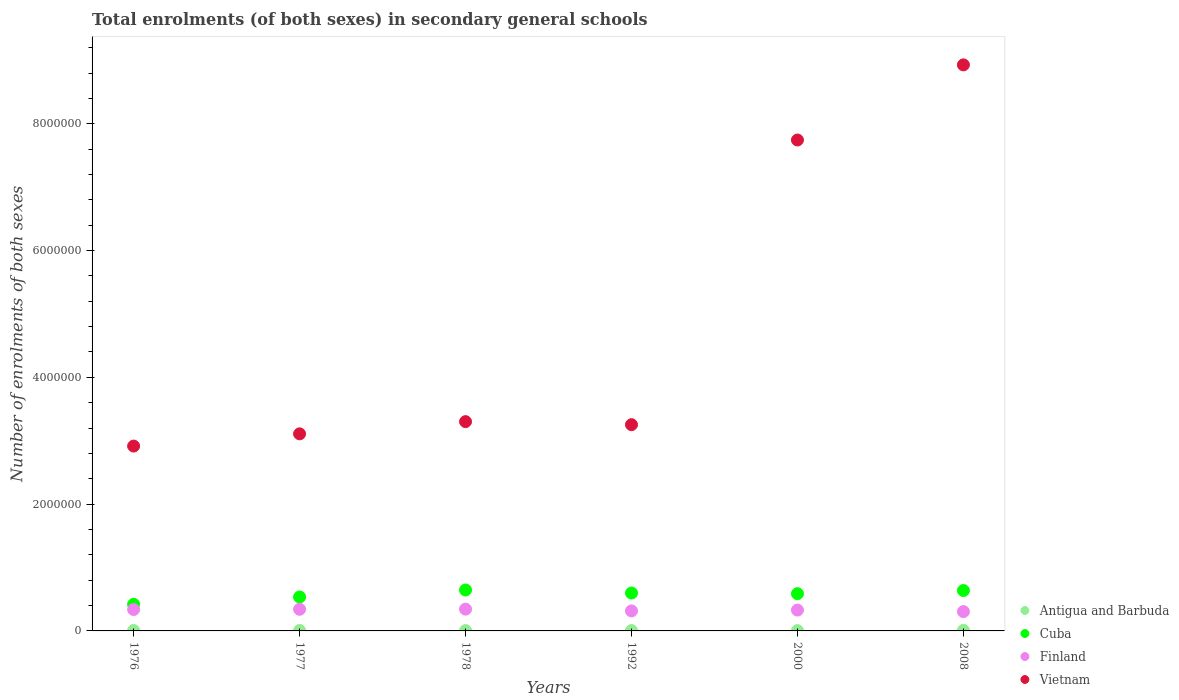Is the number of dotlines equal to the number of legend labels?
Your answer should be very brief. Yes. What is the number of enrolments in secondary schools in Cuba in 1977?
Your response must be concise. 5.35e+05. Across all years, what is the maximum number of enrolments in secondary schools in Vietnam?
Offer a very short reply. 8.93e+06. Across all years, what is the minimum number of enrolments in secondary schools in Finland?
Provide a succinct answer. 3.05e+05. In which year was the number of enrolments in secondary schools in Vietnam maximum?
Make the answer very short. 2008. In which year was the number of enrolments in secondary schools in Antigua and Barbuda minimum?
Give a very brief answer. 2000. What is the total number of enrolments in secondary schools in Cuba in the graph?
Provide a short and direct response. 3.42e+06. What is the difference between the number of enrolments in secondary schools in Finland in 1976 and that in 2008?
Make the answer very short. 3.28e+04. What is the difference between the number of enrolments in secondary schools in Antigua and Barbuda in 1992 and the number of enrolments in secondary schools in Cuba in 1977?
Offer a very short reply. -5.29e+05. What is the average number of enrolments in secondary schools in Vietnam per year?
Make the answer very short. 4.88e+06. In the year 1992, what is the difference between the number of enrolments in secondary schools in Vietnam and number of enrolments in secondary schools in Finland?
Ensure brevity in your answer.  2.94e+06. In how many years, is the number of enrolments in secondary schools in Cuba greater than 8000000?
Your answer should be very brief. 0. What is the ratio of the number of enrolments in secondary schools in Cuba in 1976 to that in 1978?
Make the answer very short. 0.65. Is the difference between the number of enrolments in secondary schools in Vietnam in 1978 and 1992 greater than the difference between the number of enrolments in secondary schools in Finland in 1978 and 1992?
Provide a short and direct response. Yes. What is the difference between the highest and the second highest number of enrolments in secondary schools in Vietnam?
Your response must be concise. 1.19e+06. What is the difference between the highest and the lowest number of enrolments in secondary schools in Antigua and Barbuda?
Offer a very short reply. 3538. In how many years, is the number of enrolments in secondary schools in Cuba greater than the average number of enrolments in secondary schools in Cuba taken over all years?
Provide a short and direct response. 4. Is the sum of the number of enrolments in secondary schools in Vietnam in 1976 and 1977 greater than the maximum number of enrolments in secondary schools in Cuba across all years?
Your answer should be very brief. Yes. Is it the case that in every year, the sum of the number of enrolments in secondary schools in Antigua and Barbuda and number of enrolments in secondary schools in Cuba  is greater than the sum of number of enrolments in secondary schools in Vietnam and number of enrolments in secondary schools in Finland?
Your answer should be compact. No. Does the number of enrolments in secondary schools in Cuba monotonically increase over the years?
Keep it short and to the point. No. Is the number of enrolments in secondary schools in Antigua and Barbuda strictly greater than the number of enrolments in secondary schools in Cuba over the years?
Offer a very short reply. No. Is the number of enrolments in secondary schools in Antigua and Barbuda strictly less than the number of enrolments in secondary schools in Cuba over the years?
Make the answer very short. Yes. What is the difference between two consecutive major ticks on the Y-axis?
Offer a terse response. 2.00e+06. Are the values on the major ticks of Y-axis written in scientific E-notation?
Your answer should be very brief. No. Does the graph contain grids?
Make the answer very short. No. Where does the legend appear in the graph?
Your response must be concise. Bottom right. How many legend labels are there?
Provide a succinct answer. 4. What is the title of the graph?
Offer a terse response. Total enrolments (of both sexes) in secondary general schools. Does "Bahrain" appear as one of the legend labels in the graph?
Provide a succinct answer. No. What is the label or title of the Y-axis?
Ensure brevity in your answer.  Number of enrolments of both sexes. What is the Number of enrolments of both sexes of Antigua and Barbuda in 1976?
Your answer should be compact. 6629. What is the Number of enrolments of both sexes in Cuba in 1976?
Provide a short and direct response. 4.20e+05. What is the Number of enrolments of both sexes in Finland in 1976?
Your response must be concise. 3.38e+05. What is the Number of enrolments of both sexes of Vietnam in 1976?
Ensure brevity in your answer.  2.92e+06. What is the Number of enrolments of both sexes of Antigua and Barbuda in 1977?
Offer a very short reply. 6685. What is the Number of enrolments of both sexes of Cuba in 1977?
Provide a short and direct response. 5.35e+05. What is the Number of enrolments of both sexes in Finland in 1977?
Keep it short and to the point. 3.41e+05. What is the Number of enrolments of both sexes in Vietnam in 1977?
Make the answer very short. 3.11e+06. What is the Number of enrolments of both sexes in Antigua and Barbuda in 1978?
Provide a succinct answer. 5458. What is the Number of enrolments of both sexes of Cuba in 1978?
Your answer should be compact. 6.46e+05. What is the Number of enrolments of both sexes in Finland in 1978?
Offer a terse response. 3.44e+05. What is the Number of enrolments of both sexes of Vietnam in 1978?
Your answer should be very brief. 3.30e+06. What is the Number of enrolments of both sexes in Antigua and Barbuda in 1992?
Give a very brief answer. 5845. What is the Number of enrolments of both sexes in Cuba in 1992?
Your answer should be very brief. 5.98e+05. What is the Number of enrolments of both sexes of Finland in 1992?
Your response must be concise. 3.16e+05. What is the Number of enrolments of both sexes of Vietnam in 1992?
Your answer should be very brief. 3.25e+06. What is the Number of enrolments of both sexes in Antigua and Barbuda in 2000?
Your response must be concise. 4576. What is the Number of enrolments of both sexes of Cuba in 2000?
Ensure brevity in your answer.  5.88e+05. What is the Number of enrolments of both sexes in Finland in 2000?
Give a very brief answer. 3.29e+05. What is the Number of enrolments of both sexes in Vietnam in 2000?
Offer a terse response. 7.74e+06. What is the Number of enrolments of both sexes in Antigua and Barbuda in 2008?
Keep it short and to the point. 8114. What is the Number of enrolments of both sexes of Cuba in 2008?
Your answer should be very brief. 6.37e+05. What is the Number of enrolments of both sexes of Finland in 2008?
Offer a very short reply. 3.05e+05. What is the Number of enrolments of both sexes in Vietnam in 2008?
Keep it short and to the point. 8.93e+06. Across all years, what is the maximum Number of enrolments of both sexes in Antigua and Barbuda?
Your answer should be very brief. 8114. Across all years, what is the maximum Number of enrolments of both sexes in Cuba?
Make the answer very short. 6.46e+05. Across all years, what is the maximum Number of enrolments of both sexes of Finland?
Offer a very short reply. 3.44e+05. Across all years, what is the maximum Number of enrolments of both sexes of Vietnam?
Your answer should be compact. 8.93e+06. Across all years, what is the minimum Number of enrolments of both sexes of Antigua and Barbuda?
Offer a terse response. 4576. Across all years, what is the minimum Number of enrolments of both sexes of Cuba?
Your response must be concise. 4.20e+05. Across all years, what is the minimum Number of enrolments of both sexes in Finland?
Give a very brief answer. 3.05e+05. Across all years, what is the minimum Number of enrolments of both sexes in Vietnam?
Offer a terse response. 2.92e+06. What is the total Number of enrolments of both sexes of Antigua and Barbuda in the graph?
Your answer should be very brief. 3.73e+04. What is the total Number of enrolments of both sexes in Cuba in the graph?
Keep it short and to the point. 3.42e+06. What is the total Number of enrolments of both sexes in Finland in the graph?
Provide a short and direct response. 1.97e+06. What is the total Number of enrolments of both sexes of Vietnam in the graph?
Your answer should be compact. 2.93e+07. What is the difference between the Number of enrolments of both sexes in Antigua and Barbuda in 1976 and that in 1977?
Your answer should be very brief. -56. What is the difference between the Number of enrolments of both sexes in Cuba in 1976 and that in 1977?
Keep it short and to the point. -1.15e+05. What is the difference between the Number of enrolments of both sexes in Finland in 1976 and that in 1977?
Your response must be concise. -3846. What is the difference between the Number of enrolments of both sexes in Vietnam in 1976 and that in 1977?
Offer a very short reply. -1.93e+05. What is the difference between the Number of enrolments of both sexes in Antigua and Barbuda in 1976 and that in 1978?
Provide a short and direct response. 1171. What is the difference between the Number of enrolments of both sexes in Cuba in 1976 and that in 1978?
Keep it short and to the point. -2.25e+05. What is the difference between the Number of enrolments of both sexes of Finland in 1976 and that in 1978?
Offer a terse response. -6184. What is the difference between the Number of enrolments of both sexes in Vietnam in 1976 and that in 1978?
Provide a succinct answer. -3.85e+05. What is the difference between the Number of enrolments of both sexes of Antigua and Barbuda in 1976 and that in 1992?
Keep it short and to the point. 784. What is the difference between the Number of enrolments of both sexes in Cuba in 1976 and that in 1992?
Your answer should be very brief. -1.78e+05. What is the difference between the Number of enrolments of both sexes of Finland in 1976 and that in 1992?
Your response must be concise. 2.17e+04. What is the difference between the Number of enrolments of both sexes in Vietnam in 1976 and that in 1992?
Your response must be concise. -3.37e+05. What is the difference between the Number of enrolments of both sexes in Antigua and Barbuda in 1976 and that in 2000?
Keep it short and to the point. 2053. What is the difference between the Number of enrolments of both sexes in Cuba in 1976 and that in 2000?
Provide a short and direct response. -1.67e+05. What is the difference between the Number of enrolments of both sexes of Finland in 1976 and that in 2000?
Make the answer very short. 8926. What is the difference between the Number of enrolments of both sexes in Vietnam in 1976 and that in 2000?
Make the answer very short. -4.83e+06. What is the difference between the Number of enrolments of both sexes of Antigua and Barbuda in 1976 and that in 2008?
Provide a short and direct response. -1485. What is the difference between the Number of enrolments of both sexes of Cuba in 1976 and that in 2008?
Keep it short and to the point. -2.17e+05. What is the difference between the Number of enrolments of both sexes in Finland in 1976 and that in 2008?
Your response must be concise. 3.28e+04. What is the difference between the Number of enrolments of both sexes of Vietnam in 1976 and that in 2008?
Your response must be concise. -6.01e+06. What is the difference between the Number of enrolments of both sexes in Antigua and Barbuda in 1977 and that in 1978?
Provide a short and direct response. 1227. What is the difference between the Number of enrolments of both sexes of Cuba in 1977 and that in 1978?
Your answer should be very brief. -1.10e+05. What is the difference between the Number of enrolments of both sexes of Finland in 1977 and that in 1978?
Your answer should be compact. -2338. What is the difference between the Number of enrolments of both sexes in Vietnam in 1977 and that in 1978?
Your response must be concise. -1.93e+05. What is the difference between the Number of enrolments of both sexes of Antigua and Barbuda in 1977 and that in 1992?
Offer a very short reply. 840. What is the difference between the Number of enrolments of both sexes in Cuba in 1977 and that in 1992?
Keep it short and to the point. -6.29e+04. What is the difference between the Number of enrolments of both sexes of Finland in 1977 and that in 1992?
Your answer should be very brief. 2.56e+04. What is the difference between the Number of enrolments of both sexes in Vietnam in 1977 and that in 1992?
Your answer should be very brief. -1.44e+05. What is the difference between the Number of enrolments of both sexes in Antigua and Barbuda in 1977 and that in 2000?
Your response must be concise. 2109. What is the difference between the Number of enrolments of both sexes in Cuba in 1977 and that in 2000?
Make the answer very short. -5.25e+04. What is the difference between the Number of enrolments of both sexes of Finland in 1977 and that in 2000?
Make the answer very short. 1.28e+04. What is the difference between the Number of enrolments of both sexes in Vietnam in 1977 and that in 2000?
Provide a short and direct response. -4.63e+06. What is the difference between the Number of enrolments of both sexes in Antigua and Barbuda in 1977 and that in 2008?
Provide a short and direct response. -1429. What is the difference between the Number of enrolments of both sexes of Cuba in 1977 and that in 2008?
Offer a very short reply. -1.02e+05. What is the difference between the Number of enrolments of both sexes in Finland in 1977 and that in 2008?
Your answer should be very brief. 3.67e+04. What is the difference between the Number of enrolments of both sexes in Vietnam in 1977 and that in 2008?
Give a very brief answer. -5.82e+06. What is the difference between the Number of enrolments of both sexes in Antigua and Barbuda in 1978 and that in 1992?
Your answer should be very brief. -387. What is the difference between the Number of enrolments of both sexes in Cuba in 1978 and that in 1992?
Provide a short and direct response. 4.76e+04. What is the difference between the Number of enrolments of both sexes in Finland in 1978 and that in 1992?
Your response must be concise. 2.79e+04. What is the difference between the Number of enrolments of both sexes in Vietnam in 1978 and that in 1992?
Offer a terse response. 4.80e+04. What is the difference between the Number of enrolments of both sexes of Antigua and Barbuda in 1978 and that in 2000?
Provide a succinct answer. 882. What is the difference between the Number of enrolments of both sexes in Cuba in 1978 and that in 2000?
Make the answer very short. 5.79e+04. What is the difference between the Number of enrolments of both sexes of Finland in 1978 and that in 2000?
Offer a very short reply. 1.51e+04. What is the difference between the Number of enrolments of both sexes of Vietnam in 1978 and that in 2000?
Your answer should be compact. -4.44e+06. What is the difference between the Number of enrolments of both sexes of Antigua and Barbuda in 1978 and that in 2008?
Offer a very short reply. -2656. What is the difference between the Number of enrolments of both sexes in Cuba in 1978 and that in 2008?
Ensure brevity in your answer.  8411. What is the difference between the Number of enrolments of both sexes of Finland in 1978 and that in 2008?
Your response must be concise. 3.90e+04. What is the difference between the Number of enrolments of both sexes of Vietnam in 1978 and that in 2008?
Your answer should be compact. -5.63e+06. What is the difference between the Number of enrolments of both sexes in Antigua and Barbuda in 1992 and that in 2000?
Keep it short and to the point. 1269. What is the difference between the Number of enrolments of both sexes of Cuba in 1992 and that in 2000?
Provide a succinct answer. 1.04e+04. What is the difference between the Number of enrolments of both sexes of Finland in 1992 and that in 2000?
Your answer should be very brief. -1.28e+04. What is the difference between the Number of enrolments of both sexes in Vietnam in 1992 and that in 2000?
Provide a short and direct response. -4.49e+06. What is the difference between the Number of enrolments of both sexes in Antigua and Barbuda in 1992 and that in 2008?
Offer a very short reply. -2269. What is the difference between the Number of enrolments of both sexes in Cuba in 1992 and that in 2008?
Ensure brevity in your answer.  -3.92e+04. What is the difference between the Number of enrolments of both sexes of Finland in 1992 and that in 2008?
Provide a short and direct response. 1.11e+04. What is the difference between the Number of enrolments of both sexes in Vietnam in 1992 and that in 2008?
Offer a terse response. -5.68e+06. What is the difference between the Number of enrolments of both sexes of Antigua and Barbuda in 2000 and that in 2008?
Provide a short and direct response. -3538. What is the difference between the Number of enrolments of both sexes in Cuba in 2000 and that in 2008?
Your answer should be compact. -4.95e+04. What is the difference between the Number of enrolments of both sexes in Finland in 2000 and that in 2008?
Offer a very short reply. 2.39e+04. What is the difference between the Number of enrolments of both sexes in Vietnam in 2000 and that in 2008?
Keep it short and to the point. -1.19e+06. What is the difference between the Number of enrolments of both sexes of Antigua and Barbuda in 1976 and the Number of enrolments of both sexes of Cuba in 1977?
Your answer should be compact. -5.28e+05. What is the difference between the Number of enrolments of both sexes of Antigua and Barbuda in 1976 and the Number of enrolments of both sexes of Finland in 1977?
Give a very brief answer. -3.35e+05. What is the difference between the Number of enrolments of both sexes of Antigua and Barbuda in 1976 and the Number of enrolments of both sexes of Vietnam in 1977?
Your response must be concise. -3.10e+06. What is the difference between the Number of enrolments of both sexes in Cuba in 1976 and the Number of enrolments of both sexes in Finland in 1977?
Ensure brevity in your answer.  7.89e+04. What is the difference between the Number of enrolments of both sexes in Cuba in 1976 and the Number of enrolments of both sexes in Vietnam in 1977?
Offer a terse response. -2.69e+06. What is the difference between the Number of enrolments of both sexes in Finland in 1976 and the Number of enrolments of both sexes in Vietnam in 1977?
Keep it short and to the point. -2.77e+06. What is the difference between the Number of enrolments of both sexes in Antigua and Barbuda in 1976 and the Number of enrolments of both sexes in Cuba in 1978?
Give a very brief answer. -6.39e+05. What is the difference between the Number of enrolments of both sexes of Antigua and Barbuda in 1976 and the Number of enrolments of both sexes of Finland in 1978?
Ensure brevity in your answer.  -3.37e+05. What is the difference between the Number of enrolments of both sexes of Antigua and Barbuda in 1976 and the Number of enrolments of both sexes of Vietnam in 1978?
Offer a terse response. -3.29e+06. What is the difference between the Number of enrolments of both sexes in Cuba in 1976 and the Number of enrolments of both sexes in Finland in 1978?
Ensure brevity in your answer.  7.66e+04. What is the difference between the Number of enrolments of both sexes of Cuba in 1976 and the Number of enrolments of both sexes of Vietnam in 1978?
Your response must be concise. -2.88e+06. What is the difference between the Number of enrolments of both sexes in Finland in 1976 and the Number of enrolments of both sexes in Vietnam in 1978?
Offer a very short reply. -2.96e+06. What is the difference between the Number of enrolments of both sexes in Antigua and Barbuda in 1976 and the Number of enrolments of both sexes in Cuba in 1992?
Make the answer very short. -5.91e+05. What is the difference between the Number of enrolments of both sexes in Antigua and Barbuda in 1976 and the Number of enrolments of both sexes in Finland in 1992?
Your answer should be very brief. -3.09e+05. What is the difference between the Number of enrolments of both sexes in Antigua and Barbuda in 1976 and the Number of enrolments of both sexes in Vietnam in 1992?
Offer a very short reply. -3.25e+06. What is the difference between the Number of enrolments of both sexes of Cuba in 1976 and the Number of enrolments of both sexes of Finland in 1992?
Your answer should be compact. 1.04e+05. What is the difference between the Number of enrolments of both sexes of Cuba in 1976 and the Number of enrolments of both sexes of Vietnam in 1992?
Provide a short and direct response. -2.83e+06. What is the difference between the Number of enrolments of both sexes of Finland in 1976 and the Number of enrolments of both sexes of Vietnam in 1992?
Your response must be concise. -2.92e+06. What is the difference between the Number of enrolments of both sexes in Antigua and Barbuda in 1976 and the Number of enrolments of both sexes in Cuba in 2000?
Provide a short and direct response. -5.81e+05. What is the difference between the Number of enrolments of both sexes in Antigua and Barbuda in 1976 and the Number of enrolments of both sexes in Finland in 2000?
Make the answer very short. -3.22e+05. What is the difference between the Number of enrolments of both sexes of Antigua and Barbuda in 1976 and the Number of enrolments of both sexes of Vietnam in 2000?
Your response must be concise. -7.74e+06. What is the difference between the Number of enrolments of both sexes in Cuba in 1976 and the Number of enrolments of both sexes in Finland in 2000?
Your answer should be very brief. 9.17e+04. What is the difference between the Number of enrolments of both sexes in Cuba in 1976 and the Number of enrolments of both sexes in Vietnam in 2000?
Provide a succinct answer. -7.32e+06. What is the difference between the Number of enrolments of both sexes in Finland in 1976 and the Number of enrolments of both sexes in Vietnam in 2000?
Provide a succinct answer. -7.41e+06. What is the difference between the Number of enrolments of both sexes in Antigua and Barbuda in 1976 and the Number of enrolments of both sexes in Cuba in 2008?
Give a very brief answer. -6.31e+05. What is the difference between the Number of enrolments of both sexes of Antigua and Barbuda in 1976 and the Number of enrolments of both sexes of Finland in 2008?
Ensure brevity in your answer.  -2.98e+05. What is the difference between the Number of enrolments of both sexes of Antigua and Barbuda in 1976 and the Number of enrolments of both sexes of Vietnam in 2008?
Your answer should be very brief. -8.92e+06. What is the difference between the Number of enrolments of both sexes in Cuba in 1976 and the Number of enrolments of both sexes in Finland in 2008?
Your answer should be very brief. 1.16e+05. What is the difference between the Number of enrolments of both sexes of Cuba in 1976 and the Number of enrolments of both sexes of Vietnam in 2008?
Make the answer very short. -8.51e+06. What is the difference between the Number of enrolments of both sexes of Finland in 1976 and the Number of enrolments of both sexes of Vietnam in 2008?
Ensure brevity in your answer.  -8.59e+06. What is the difference between the Number of enrolments of both sexes of Antigua and Barbuda in 1977 and the Number of enrolments of both sexes of Cuba in 1978?
Provide a succinct answer. -6.39e+05. What is the difference between the Number of enrolments of both sexes of Antigua and Barbuda in 1977 and the Number of enrolments of both sexes of Finland in 1978?
Make the answer very short. -3.37e+05. What is the difference between the Number of enrolments of both sexes of Antigua and Barbuda in 1977 and the Number of enrolments of both sexes of Vietnam in 1978?
Your answer should be very brief. -3.29e+06. What is the difference between the Number of enrolments of both sexes of Cuba in 1977 and the Number of enrolments of both sexes of Finland in 1978?
Keep it short and to the point. 1.91e+05. What is the difference between the Number of enrolments of both sexes in Cuba in 1977 and the Number of enrolments of both sexes in Vietnam in 1978?
Provide a succinct answer. -2.77e+06. What is the difference between the Number of enrolments of both sexes of Finland in 1977 and the Number of enrolments of both sexes of Vietnam in 1978?
Ensure brevity in your answer.  -2.96e+06. What is the difference between the Number of enrolments of both sexes in Antigua and Barbuda in 1977 and the Number of enrolments of both sexes in Cuba in 1992?
Offer a very short reply. -5.91e+05. What is the difference between the Number of enrolments of both sexes in Antigua and Barbuda in 1977 and the Number of enrolments of both sexes in Finland in 1992?
Ensure brevity in your answer.  -3.09e+05. What is the difference between the Number of enrolments of both sexes of Antigua and Barbuda in 1977 and the Number of enrolments of both sexes of Vietnam in 1992?
Provide a succinct answer. -3.25e+06. What is the difference between the Number of enrolments of both sexes of Cuba in 1977 and the Number of enrolments of both sexes of Finland in 1992?
Give a very brief answer. 2.19e+05. What is the difference between the Number of enrolments of both sexes of Cuba in 1977 and the Number of enrolments of both sexes of Vietnam in 1992?
Give a very brief answer. -2.72e+06. What is the difference between the Number of enrolments of both sexes of Finland in 1977 and the Number of enrolments of both sexes of Vietnam in 1992?
Keep it short and to the point. -2.91e+06. What is the difference between the Number of enrolments of both sexes of Antigua and Barbuda in 1977 and the Number of enrolments of both sexes of Cuba in 2000?
Your answer should be very brief. -5.81e+05. What is the difference between the Number of enrolments of both sexes in Antigua and Barbuda in 1977 and the Number of enrolments of both sexes in Finland in 2000?
Provide a short and direct response. -3.22e+05. What is the difference between the Number of enrolments of both sexes of Antigua and Barbuda in 1977 and the Number of enrolments of both sexes of Vietnam in 2000?
Offer a terse response. -7.74e+06. What is the difference between the Number of enrolments of both sexes of Cuba in 1977 and the Number of enrolments of both sexes of Finland in 2000?
Offer a very short reply. 2.06e+05. What is the difference between the Number of enrolments of both sexes in Cuba in 1977 and the Number of enrolments of both sexes in Vietnam in 2000?
Provide a succinct answer. -7.21e+06. What is the difference between the Number of enrolments of both sexes in Finland in 1977 and the Number of enrolments of both sexes in Vietnam in 2000?
Give a very brief answer. -7.40e+06. What is the difference between the Number of enrolments of both sexes in Antigua and Barbuda in 1977 and the Number of enrolments of both sexes in Cuba in 2008?
Ensure brevity in your answer.  -6.30e+05. What is the difference between the Number of enrolments of both sexes in Antigua and Barbuda in 1977 and the Number of enrolments of both sexes in Finland in 2008?
Provide a short and direct response. -2.98e+05. What is the difference between the Number of enrolments of both sexes of Antigua and Barbuda in 1977 and the Number of enrolments of both sexes of Vietnam in 2008?
Give a very brief answer. -8.92e+06. What is the difference between the Number of enrolments of both sexes of Cuba in 1977 and the Number of enrolments of both sexes of Finland in 2008?
Keep it short and to the point. 2.30e+05. What is the difference between the Number of enrolments of both sexes of Cuba in 1977 and the Number of enrolments of both sexes of Vietnam in 2008?
Provide a succinct answer. -8.39e+06. What is the difference between the Number of enrolments of both sexes in Finland in 1977 and the Number of enrolments of both sexes in Vietnam in 2008?
Give a very brief answer. -8.59e+06. What is the difference between the Number of enrolments of both sexes in Antigua and Barbuda in 1978 and the Number of enrolments of both sexes in Cuba in 1992?
Your response must be concise. -5.93e+05. What is the difference between the Number of enrolments of both sexes in Antigua and Barbuda in 1978 and the Number of enrolments of both sexes in Finland in 1992?
Your response must be concise. -3.10e+05. What is the difference between the Number of enrolments of both sexes of Antigua and Barbuda in 1978 and the Number of enrolments of both sexes of Vietnam in 1992?
Ensure brevity in your answer.  -3.25e+06. What is the difference between the Number of enrolments of both sexes in Cuba in 1978 and the Number of enrolments of both sexes in Finland in 1992?
Your response must be concise. 3.30e+05. What is the difference between the Number of enrolments of both sexes of Cuba in 1978 and the Number of enrolments of both sexes of Vietnam in 1992?
Provide a short and direct response. -2.61e+06. What is the difference between the Number of enrolments of both sexes in Finland in 1978 and the Number of enrolments of both sexes in Vietnam in 1992?
Ensure brevity in your answer.  -2.91e+06. What is the difference between the Number of enrolments of both sexes of Antigua and Barbuda in 1978 and the Number of enrolments of both sexes of Cuba in 2000?
Make the answer very short. -5.82e+05. What is the difference between the Number of enrolments of both sexes of Antigua and Barbuda in 1978 and the Number of enrolments of both sexes of Finland in 2000?
Offer a terse response. -3.23e+05. What is the difference between the Number of enrolments of both sexes of Antigua and Barbuda in 1978 and the Number of enrolments of both sexes of Vietnam in 2000?
Provide a succinct answer. -7.74e+06. What is the difference between the Number of enrolments of both sexes in Cuba in 1978 and the Number of enrolments of both sexes in Finland in 2000?
Offer a terse response. 3.17e+05. What is the difference between the Number of enrolments of both sexes of Cuba in 1978 and the Number of enrolments of both sexes of Vietnam in 2000?
Provide a succinct answer. -7.10e+06. What is the difference between the Number of enrolments of both sexes of Finland in 1978 and the Number of enrolments of both sexes of Vietnam in 2000?
Offer a very short reply. -7.40e+06. What is the difference between the Number of enrolments of both sexes of Antigua and Barbuda in 1978 and the Number of enrolments of both sexes of Cuba in 2008?
Offer a very short reply. -6.32e+05. What is the difference between the Number of enrolments of both sexes of Antigua and Barbuda in 1978 and the Number of enrolments of both sexes of Finland in 2008?
Provide a short and direct response. -2.99e+05. What is the difference between the Number of enrolments of both sexes of Antigua and Barbuda in 1978 and the Number of enrolments of both sexes of Vietnam in 2008?
Give a very brief answer. -8.92e+06. What is the difference between the Number of enrolments of both sexes in Cuba in 1978 and the Number of enrolments of both sexes in Finland in 2008?
Keep it short and to the point. 3.41e+05. What is the difference between the Number of enrolments of both sexes in Cuba in 1978 and the Number of enrolments of both sexes in Vietnam in 2008?
Offer a very short reply. -8.28e+06. What is the difference between the Number of enrolments of both sexes of Finland in 1978 and the Number of enrolments of both sexes of Vietnam in 2008?
Keep it short and to the point. -8.58e+06. What is the difference between the Number of enrolments of both sexes in Antigua and Barbuda in 1992 and the Number of enrolments of both sexes in Cuba in 2000?
Your answer should be compact. -5.82e+05. What is the difference between the Number of enrolments of both sexes of Antigua and Barbuda in 1992 and the Number of enrolments of both sexes of Finland in 2000?
Ensure brevity in your answer.  -3.23e+05. What is the difference between the Number of enrolments of both sexes of Antigua and Barbuda in 1992 and the Number of enrolments of both sexes of Vietnam in 2000?
Your answer should be compact. -7.74e+06. What is the difference between the Number of enrolments of both sexes in Cuba in 1992 and the Number of enrolments of both sexes in Finland in 2000?
Keep it short and to the point. 2.69e+05. What is the difference between the Number of enrolments of both sexes of Cuba in 1992 and the Number of enrolments of both sexes of Vietnam in 2000?
Provide a short and direct response. -7.15e+06. What is the difference between the Number of enrolments of both sexes of Finland in 1992 and the Number of enrolments of both sexes of Vietnam in 2000?
Your response must be concise. -7.43e+06. What is the difference between the Number of enrolments of both sexes of Antigua and Barbuda in 1992 and the Number of enrolments of both sexes of Cuba in 2008?
Give a very brief answer. -6.31e+05. What is the difference between the Number of enrolments of both sexes of Antigua and Barbuda in 1992 and the Number of enrolments of both sexes of Finland in 2008?
Ensure brevity in your answer.  -2.99e+05. What is the difference between the Number of enrolments of both sexes of Antigua and Barbuda in 1992 and the Number of enrolments of both sexes of Vietnam in 2008?
Make the answer very short. -8.92e+06. What is the difference between the Number of enrolments of both sexes of Cuba in 1992 and the Number of enrolments of both sexes of Finland in 2008?
Provide a short and direct response. 2.93e+05. What is the difference between the Number of enrolments of both sexes in Cuba in 1992 and the Number of enrolments of both sexes in Vietnam in 2008?
Offer a terse response. -8.33e+06. What is the difference between the Number of enrolments of both sexes of Finland in 1992 and the Number of enrolments of both sexes of Vietnam in 2008?
Make the answer very short. -8.61e+06. What is the difference between the Number of enrolments of both sexes in Antigua and Barbuda in 2000 and the Number of enrolments of both sexes in Cuba in 2008?
Ensure brevity in your answer.  -6.33e+05. What is the difference between the Number of enrolments of both sexes in Antigua and Barbuda in 2000 and the Number of enrolments of both sexes in Finland in 2008?
Keep it short and to the point. -3.00e+05. What is the difference between the Number of enrolments of both sexes in Antigua and Barbuda in 2000 and the Number of enrolments of both sexes in Vietnam in 2008?
Offer a terse response. -8.92e+06. What is the difference between the Number of enrolments of both sexes in Cuba in 2000 and the Number of enrolments of both sexes in Finland in 2008?
Keep it short and to the point. 2.83e+05. What is the difference between the Number of enrolments of both sexes of Cuba in 2000 and the Number of enrolments of both sexes of Vietnam in 2008?
Your answer should be very brief. -8.34e+06. What is the difference between the Number of enrolments of both sexes of Finland in 2000 and the Number of enrolments of both sexes of Vietnam in 2008?
Provide a succinct answer. -8.60e+06. What is the average Number of enrolments of both sexes of Antigua and Barbuda per year?
Provide a succinct answer. 6217.83. What is the average Number of enrolments of both sexes of Cuba per year?
Ensure brevity in your answer.  5.71e+05. What is the average Number of enrolments of both sexes in Finland per year?
Offer a very short reply. 3.29e+05. What is the average Number of enrolments of both sexes in Vietnam per year?
Keep it short and to the point. 4.88e+06. In the year 1976, what is the difference between the Number of enrolments of both sexes in Antigua and Barbuda and Number of enrolments of both sexes in Cuba?
Your answer should be very brief. -4.14e+05. In the year 1976, what is the difference between the Number of enrolments of both sexes in Antigua and Barbuda and Number of enrolments of both sexes in Finland?
Ensure brevity in your answer.  -3.31e+05. In the year 1976, what is the difference between the Number of enrolments of both sexes in Antigua and Barbuda and Number of enrolments of both sexes in Vietnam?
Your response must be concise. -2.91e+06. In the year 1976, what is the difference between the Number of enrolments of both sexes of Cuba and Number of enrolments of both sexes of Finland?
Provide a short and direct response. 8.27e+04. In the year 1976, what is the difference between the Number of enrolments of both sexes of Cuba and Number of enrolments of both sexes of Vietnam?
Keep it short and to the point. -2.50e+06. In the year 1976, what is the difference between the Number of enrolments of both sexes of Finland and Number of enrolments of both sexes of Vietnam?
Provide a succinct answer. -2.58e+06. In the year 1977, what is the difference between the Number of enrolments of both sexes of Antigua and Barbuda and Number of enrolments of both sexes of Cuba?
Ensure brevity in your answer.  -5.28e+05. In the year 1977, what is the difference between the Number of enrolments of both sexes in Antigua and Barbuda and Number of enrolments of both sexes in Finland?
Provide a short and direct response. -3.35e+05. In the year 1977, what is the difference between the Number of enrolments of both sexes of Antigua and Barbuda and Number of enrolments of both sexes of Vietnam?
Provide a short and direct response. -3.10e+06. In the year 1977, what is the difference between the Number of enrolments of both sexes of Cuba and Number of enrolments of both sexes of Finland?
Ensure brevity in your answer.  1.94e+05. In the year 1977, what is the difference between the Number of enrolments of both sexes in Cuba and Number of enrolments of both sexes in Vietnam?
Your response must be concise. -2.57e+06. In the year 1977, what is the difference between the Number of enrolments of both sexes of Finland and Number of enrolments of both sexes of Vietnam?
Your answer should be very brief. -2.77e+06. In the year 1978, what is the difference between the Number of enrolments of both sexes in Antigua and Barbuda and Number of enrolments of both sexes in Cuba?
Your answer should be very brief. -6.40e+05. In the year 1978, what is the difference between the Number of enrolments of both sexes of Antigua and Barbuda and Number of enrolments of both sexes of Finland?
Give a very brief answer. -3.38e+05. In the year 1978, what is the difference between the Number of enrolments of both sexes of Antigua and Barbuda and Number of enrolments of both sexes of Vietnam?
Provide a succinct answer. -3.30e+06. In the year 1978, what is the difference between the Number of enrolments of both sexes in Cuba and Number of enrolments of both sexes in Finland?
Your answer should be compact. 3.02e+05. In the year 1978, what is the difference between the Number of enrolments of both sexes in Cuba and Number of enrolments of both sexes in Vietnam?
Make the answer very short. -2.66e+06. In the year 1978, what is the difference between the Number of enrolments of both sexes of Finland and Number of enrolments of both sexes of Vietnam?
Provide a succinct answer. -2.96e+06. In the year 1992, what is the difference between the Number of enrolments of both sexes in Antigua and Barbuda and Number of enrolments of both sexes in Cuba?
Offer a terse response. -5.92e+05. In the year 1992, what is the difference between the Number of enrolments of both sexes of Antigua and Barbuda and Number of enrolments of both sexes of Finland?
Offer a terse response. -3.10e+05. In the year 1992, what is the difference between the Number of enrolments of both sexes of Antigua and Barbuda and Number of enrolments of both sexes of Vietnam?
Give a very brief answer. -3.25e+06. In the year 1992, what is the difference between the Number of enrolments of both sexes of Cuba and Number of enrolments of both sexes of Finland?
Make the answer very short. 2.82e+05. In the year 1992, what is the difference between the Number of enrolments of both sexes of Cuba and Number of enrolments of both sexes of Vietnam?
Offer a terse response. -2.66e+06. In the year 1992, what is the difference between the Number of enrolments of both sexes of Finland and Number of enrolments of both sexes of Vietnam?
Your answer should be very brief. -2.94e+06. In the year 2000, what is the difference between the Number of enrolments of both sexes in Antigua and Barbuda and Number of enrolments of both sexes in Cuba?
Offer a terse response. -5.83e+05. In the year 2000, what is the difference between the Number of enrolments of both sexes of Antigua and Barbuda and Number of enrolments of both sexes of Finland?
Offer a terse response. -3.24e+05. In the year 2000, what is the difference between the Number of enrolments of both sexes in Antigua and Barbuda and Number of enrolments of both sexes in Vietnam?
Your answer should be very brief. -7.74e+06. In the year 2000, what is the difference between the Number of enrolments of both sexes of Cuba and Number of enrolments of both sexes of Finland?
Make the answer very short. 2.59e+05. In the year 2000, what is the difference between the Number of enrolments of both sexes in Cuba and Number of enrolments of both sexes in Vietnam?
Ensure brevity in your answer.  -7.16e+06. In the year 2000, what is the difference between the Number of enrolments of both sexes in Finland and Number of enrolments of both sexes in Vietnam?
Provide a succinct answer. -7.41e+06. In the year 2008, what is the difference between the Number of enrolments of both sexes of Antigua and Barbuda and Number of enrolments of both sexes of Cuba?
Your response must be concise. -6.29e+05. In the year 2008, what is the difference between the Number of enrolments of both sexes of Antigua and Barbuda and Number of enrolments of both sexes of Finland?
Your answer should be very brief. -2.97e+05. In the year 2008, what is the difference between the Number of enrolments of both sexes in Antigua and Barbuda and Number of enrolments of both sexes in Vietnam?
Offer a very short reply. -8.92e+06. In the year 2008, what is the difference between the Number of enrolments of both sexes of Cuba and Number of enrolments of both sexes of Finland?
Provide a short and direct response. 3.32e+05. In the year 2008, what is the difference between the Number of enrolments of both sexes in Cuba and Number of enrolments of both sexes in Vietnam?
Provide a short and direct response. -8.29e+06. In the year 2008, what is the difference between the Number of enrolments of both sexes in Finland and Number of enrolments of both sexes in Vietnam?
Provide a succinct answer. -8.62e+06. What is the ratio of the Number of enrolments of both sexes in Antigua and Barbuda in 1976 to that in 1977?
Your response must be concise. 0.99. What is the ratio of the Number of enrolments of both sexes of Cuba in 1976 to that in 1977?
Offer a terse response. 0.79. What is the ratio of the Number of enrolments of both sexes of Finland in 1976 to that in 1977?
Your response must be concise. 0.99. What is the ratio of the Number of enrolments of both sexes of Vietnam in 1976 to that in 1977?
Offer a terse response. 0.94. What is the ratio of the Number of enrolments of both sexes of Antigua and Barbuda in 1976 to that in 1978?
Provide a succinct answer. 1.21. What is the ratio of the Number of enrolments of both sexes of Cuba in 1976 to that in 1978?
Your answer should be very brief. 0.65. What is the ratio of the Number of enrolments of both sexes in Finland in 1976 to that in 1978?
Keep it short and to the point. 0.98. What is the ratio of the Number of enrolments of both sexes of Vietnam in 1976 to that in 1978?
Provide a short and direct response. 0.88. What is the ratio of the Number of enrolments of both sexes in Antigua and Barbuda in 1976 to that in 1992?
Ensure brevity in your answer.  1.13. What is the ratio of the Number of enrolments of both sexes of Cuba in 1976 to that in 1992?
Provide a short and direct response. 0.7. What is the ratio of the Number of enrolments of both sexes of Finland in 1976 to that in 1992?
Your answer should be very brief. 1.07. What is the ratio of the Number of enrolments of both sexes of Vietnam in 1976 to that in 1992?
Your answer should be compact. 0.9. What is the ratio of the Number of enrolments of both sexes of Antigua and Barbuda in 1976 to that in 2000?
Provide a succinct answer. 1.45. What is the ratio of the Number of enrolments of both sexes in Cuba in 1976 to that in 2000?
Make the answer very short. 0.72. What is the ratio of the Number of enrolments of both sexes of Finland in 1976 to that in 2000?
Offer a very short reply. 1.03. What is the ratio of the Number of enrolments of both sexes in Vietnam in 1976 to that in 2000?
Provide a short and direct response. 0.38. What is the ratio of the Number of enrolments of both sexes of Antigua and Barbuda in 1976 to that in 2008?
Make the answer very short. 0.82. What is the ratio of the Number of enrolments of both sexes in Cuba in 1976 to that in 2008?
Your answer should be very brief. 0.66. What is the ratio of the Number of enrolments of both sexes of Finland in 1976 to that in 2008?
Make the answer very short. 1.11. What is the ratio of the Number of enrolments of both sexes of Vietnam in 1976 to that in 2008?
Keep it short and to the point. 0.33. What is the ratio of the Number of enrolments of both sexes of Antigua and Barbuda in 1977 to that in 1978?
Ensure brevity in your answer.  1.22. What is the ratio of the Number of enrolments of both sexes in Cuba in 1977 to that in 1978?
Your response must be concise. 0.83. What is the ratio of the Number of enrolments of both sexes of Finland in 1977 to that in 1978?
Ensure brevity in your answer.  0.99. What is the ratio of the Number of enrolments of both sexes in Vietnam in 1977 to that in 1978?
Your answer should be very brief. 0.94. What is the ratio of the Number of enrolments of both sexes of Antigua and Barbuda in 1977 to that in 1992?
Your answer should be compact. 1.14. What is the ratio of the Number of enrolments of both sexes in Cuba in 1977 to that in 1992?
Ensure brevity in your answer.  0.89. What is the ratio of the Number of enrolments of both sexes of Finland in 1977 to that in 1992?
Keep it short and to the point. 1.08. What is the ratio of the Number of enrolments of both sexes of Vietnam in 1977 to that in 1992?
Your answer should be very brief. 0.96. What is the ratio of the Number of enrolments of both sexes of Antigua and Barbuda in 1977 to that in 2000?
Provide a short and direct response. 1.46. What is the ratio of the Number of enrolments of both sexes in Cuba in 1977 to that in 2000?
Make the answer very short. 0.91. What is the ratio of the Number of enrolments of both sexes in Finland in 1977 to that in 2000?
Offer a very short reply. 1.04. What is the ratio of the Number of enrolments of both sexes in Vietnam in 1977 to that in 2000?
Make the answer very short. 0.4. What is the ratio of the Number of enrolments of both sexes of Antigua and Barbuda in 1977 to that in 2008?
Provide a succinct answer. 0.82. What is the ratio of the Number of enrolments of both sexes in Cuba in 1977 to that in 2008?
Your answer should be very brief. 0.84. What is the ratio of the Number of enrolments of both sexes in Finland in 1977 to that in 2008?
Your response must be concise. 1.12. What is the ratio of the Number of enrolments of both sexes in Vietnam in 1977 to that in 2008?
Keep it short and to the point. 0.35. What is the ratio of the Number of enrolments of both sexes in Antigua and Barbuda in 1978 to that in 1992?
Your response must be concise. 0.93. What is the ratio of the Number of enrolments of both sexes in Cuba in 1978 to that in 1992?
Your answer should be compact. 1.08. What is the ratio of the Number of enrolments of both sexes in Finland in 1978 to that in 1992?
Keep it short and to the point. 1.09. What is the ratio of the Number of enrolments of both sexes in Vietnam in 1978 to that in 1992?
Your response must be concise. 1.01. What is the ratio of the Number of enrolments of both sexes in Antigua and Barbuda in 1978 to that in 2000?
Provide a succinct answer. 1.19. What is the ratio of the Number of enrolments of both sexes in Cuba in 1978 to that in 2000?
Keep it short and to the point. 1.1. What is the ratio of the Number of enrolments of both sexes of Finland in 1978 to that in 2000?
Offer a terse response. 1.05. What is the ratio of the Number of enrolments of both sexes of Vietnam in 1978 to that in 2000?
Keep it short and to the point. 0.43. What is the ratio of the Number of enrolments of both sexes of Antigua and Barbuda in 1978 to that in 2008?
Your response must be concise. 0.67. What is the ratio of the Number of enrolments of both sexes of Cuba in 1978 to that in 2008?
Your answer should be very brief. 1.01. What is the ratio of the Number of enrolments of both sexes of Finland in 1978 to that in 2008?
Your answer should be very brief. 1.13. What is the ratio of the Number of enrolments of both sexes of Vietnam in 1978 to that in 2008?
Provide a succinct answer. 0.37. What is the ratio of the Number of enrolments of both sexes of Antigua and Barbuda in 1992 to that in 2000?
Offer a very short reply. 1.28. What is the ratio of the Number of enrolments of both sexes of Cuba in 1992 to that in 2000?
Offer a terse response. 1.02. What is the ratio of the Number of enrolments of both sexes of Finland in 1992 to that in 2000?
Your response must be concise. 0.96. What is the ratio of the Number of enrolments of both sexes in Vietnam in 1992 to that in 2000?
Provide a succinct answer. 0.42. What is the ratio of the Number of enrolments of both sexes in Antigua and Barbuda in 1992 to that in 2008?
Provide a succinct answer. 0.72. What is the ratio of the Number of enrolments of both sexes in Cuba in 1992 to that in 2008?
Provide a succinct answer. 0.94. What is the ratio of the Number of enrolments of both sexes in Finland in 1992 to that in 2008?
Your answer should be very brief. 1.04. What is the ratio of the Number of enrolments of both sexes of Vietnam in 1992 to that in 2008?
Give a very brief answer. 0.36. What is the ratio of the Number of enrolments of both sexes of Antigua and Barbuda in 2000 to that in 2008?
Offer a terse response. 0.56. What is the ratio of the Number of enrolments of both sexes in Cuba in 2000 to that in 2008?
Give a very brief answer. 0.92. What is the ratio of the Number of enrolments of both sexes of Finland in 2000 to that in 2008?
Offer a terse response. 1.08. What is the ratio of the Number of enrolments of both sexes of Vietnam in 2000 to that in 2008?
Ensure brevity in your answer.  0.87. What is the difference between the highest and the second highest Number of enrolments of both sexes in Antigua and Barbuda?
Ensure brevity in your answer.  1429. What is the difference between the highest and the second highest Number of enrolments of both sexes of Cuba?
Your response must be concise. 8411. What is the difference between the highest and the second highest Number of enrolments of both sexes in Finland?
Your answer should be very brief. 2338. What is the difference between the highest and the second highest Number of enrolments of both sexes in Vietnam?
Make the answer very short. 1.19e+06. What is the difference between the highest and the lowest Number of enrolments of both sexes in Antigua and Barbuda?
Offer a very short reply. 3538. What is the difference between the highest and the lowest Number of enrolments of both sexes in Cuba?
Give a very brief answer. 2.25e+05. What is the difference between the highest and the lowest Number of enrolments of both sexes in Finland?
Your response must be concise. 3.90e+04. What is the difference between the highest and the lowest Number of enrolments of both sexes of Vietnam?
Keep it short and to the point. 6.01e+06. 